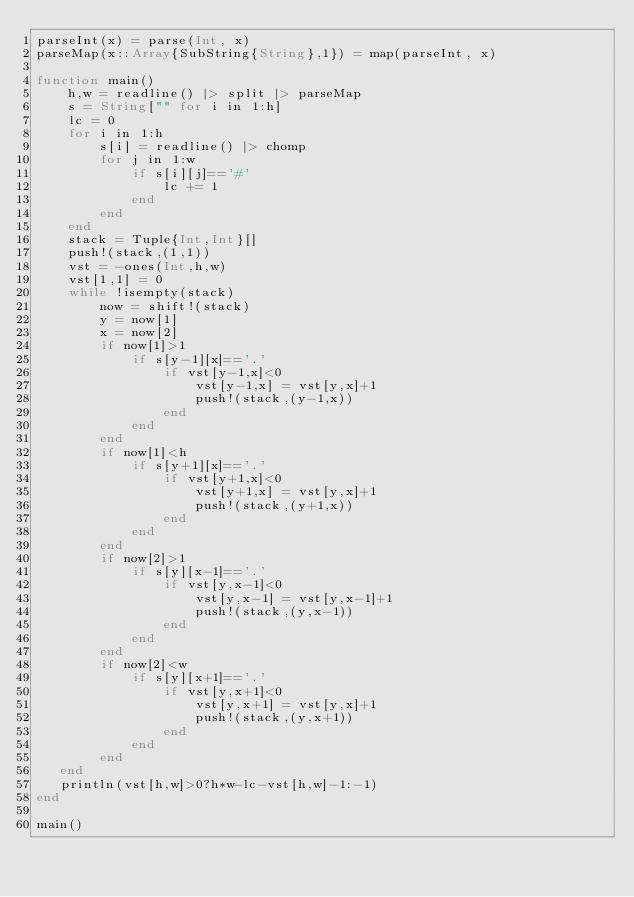Convert code to text. <code><loc_0><loc_0><loc_500><loc_500><_Julia_>parseInt(x) = parse(Int, x)
parseMap(x::Array{SubString{String},1}) = map(parseInt, x)

function main()
    h,w = readline() |> split |> parseMap
    s = String["" for i in 1:h]
    lc = 0
    for i in 1:h
        s[i] = readline() |> chomp
        for j in 1:w
            if s[i][j]=='#'
                lc += 1
            end
        end
    end
    stack = Tuple{Int,Int}[]
    push!(stack,(1,1))
    vst = -ones(Int,h,w)
    vst[1,1] = 0
    while !isempty(stack)
        now = shift!(stack)
        y = now[1]
        x = now[2]
        if now[1]>1
            if s[y-1][x]=='.'
                if vst[y-1,x]<0
                    vst[y-1,x] = vst[y,x]+1
                    push!(stack,(y-1,x))
                end
            end
        end
        if now[1]<h
            if s[y+1][x]=='.'
                if vst[y+1,x]<0
                    vst[y+1,x] = vst[y,x]+1
                    push!(stack,(y+1,x))
                end
            end
        end
        if now[2]>1
            if s[y][x-1]=='.'
                if vst[y,x-1]<0
                    vst[y,x-1] = vst[y,x-1]+1
                    push!(stack,(y,x-1))
                end
            end
        end
        if now[2]<w
            if s[y][x+1]=='.'
                if vst[y,x+1]<0
                    vst[y,x+1] = vst[y,x]+1
                    push!(stack,(y,x+1))
                end
            end
        end
   end
   println(vst[h,w]>0?h*w-lc-vst[h,w]-1:-1)
end

main()</code> 